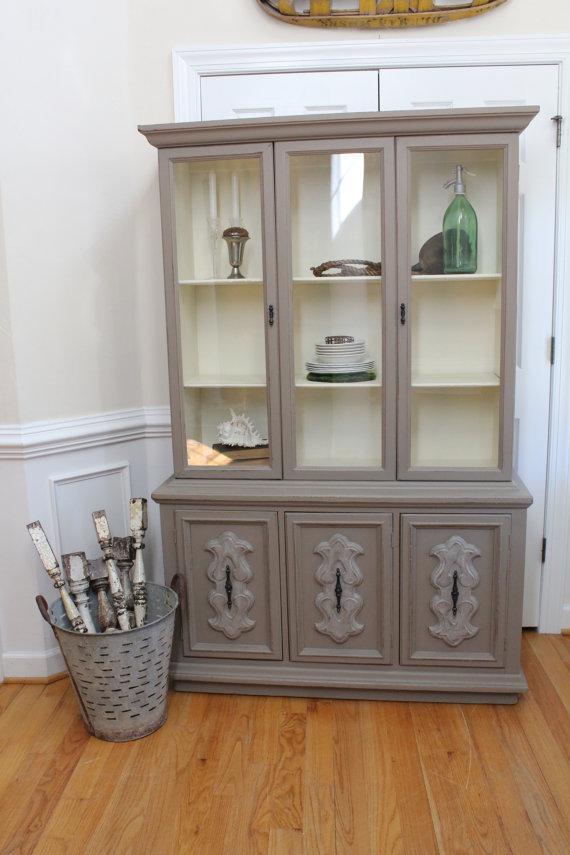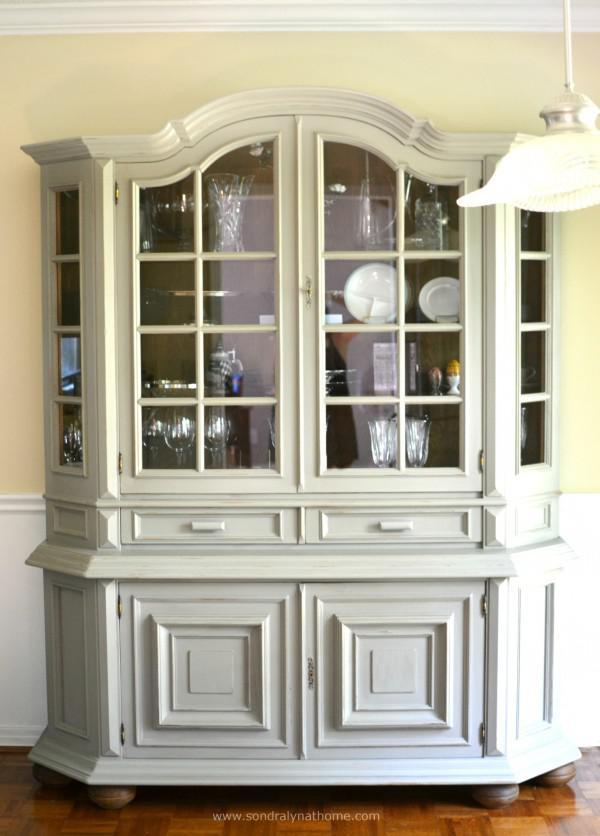The first image is the image on the left, the second image is the image on the right. Considering the images on both sides, is "An image features a cabinet with an arched top and at least two glass doors." valid? Answer yes or no. Yes. The first image is the image on the left, the second image is the image on the right. Given the left and right images, does the statement "One flat topped wooden hutch has the same number of glass doors in its upper section as solid doors in its lower section and sits flush to the floor." hold true? Answer yes or no. Yes. 